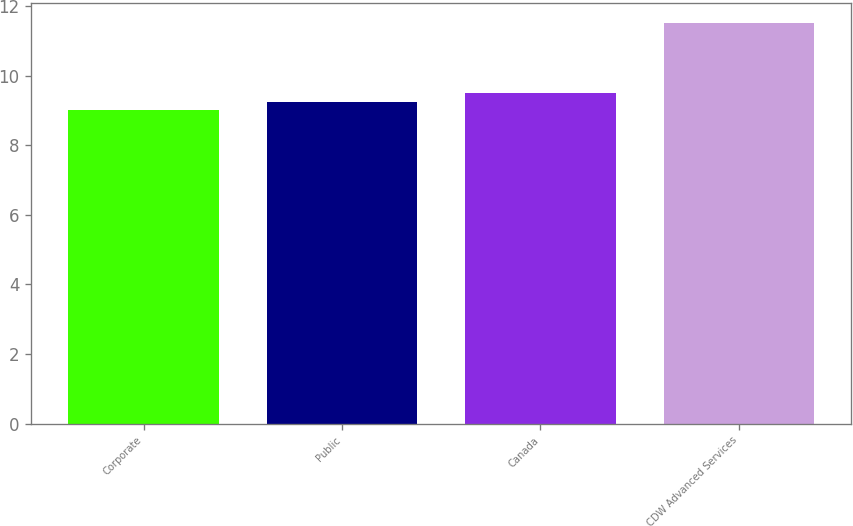Convert chart to OTSL. <chart><loc_0><loc_0><loc_500><loc_500><bar_chart><fcel>Corporate<fcel>Public<fcel>Canada<fcel>CDW Advanced Services<nl><fcel>9<fcel>9.25<fcel>9.5<fcel>11.5<nl></chart> 